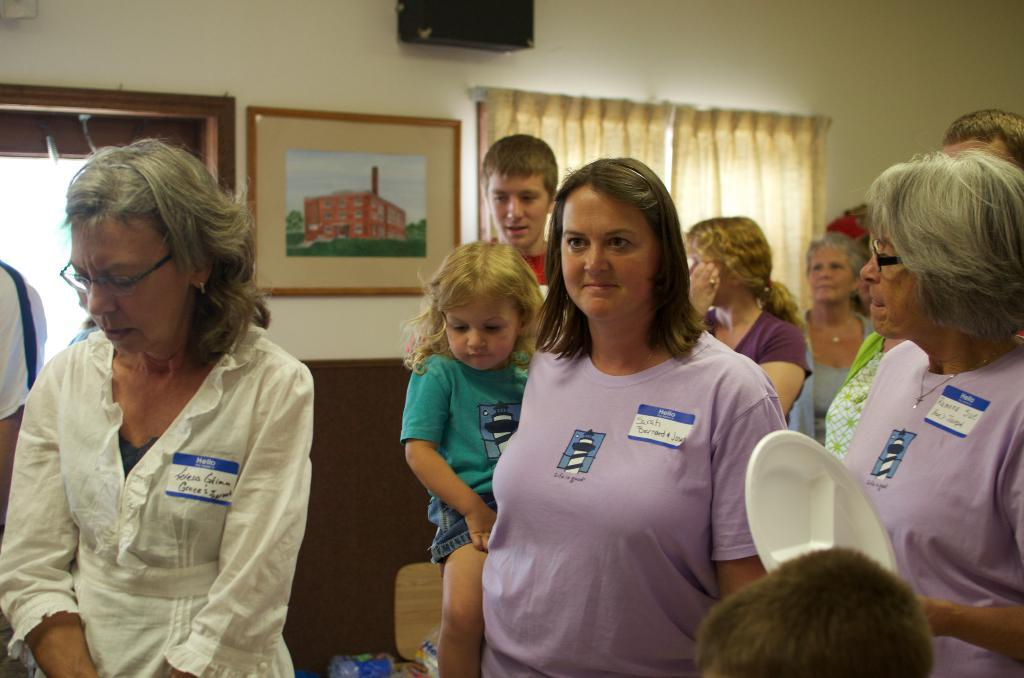How many people are present in the room in the image? There are many people in the room in the image. What is the person on the right holding? The person on the right is holding a white plate. Can you describe any decorative elements in the image? There is a photo frame in the image. What architectural features can be seen in the image? There are windows and curtains in the image. What type of lace is used for the curtains in the image? There is no mention of lace in the image, and the curtains' material is not specified. What is the average income of the people in the image? The income of the people in the image cannot be determined from the image itself. 